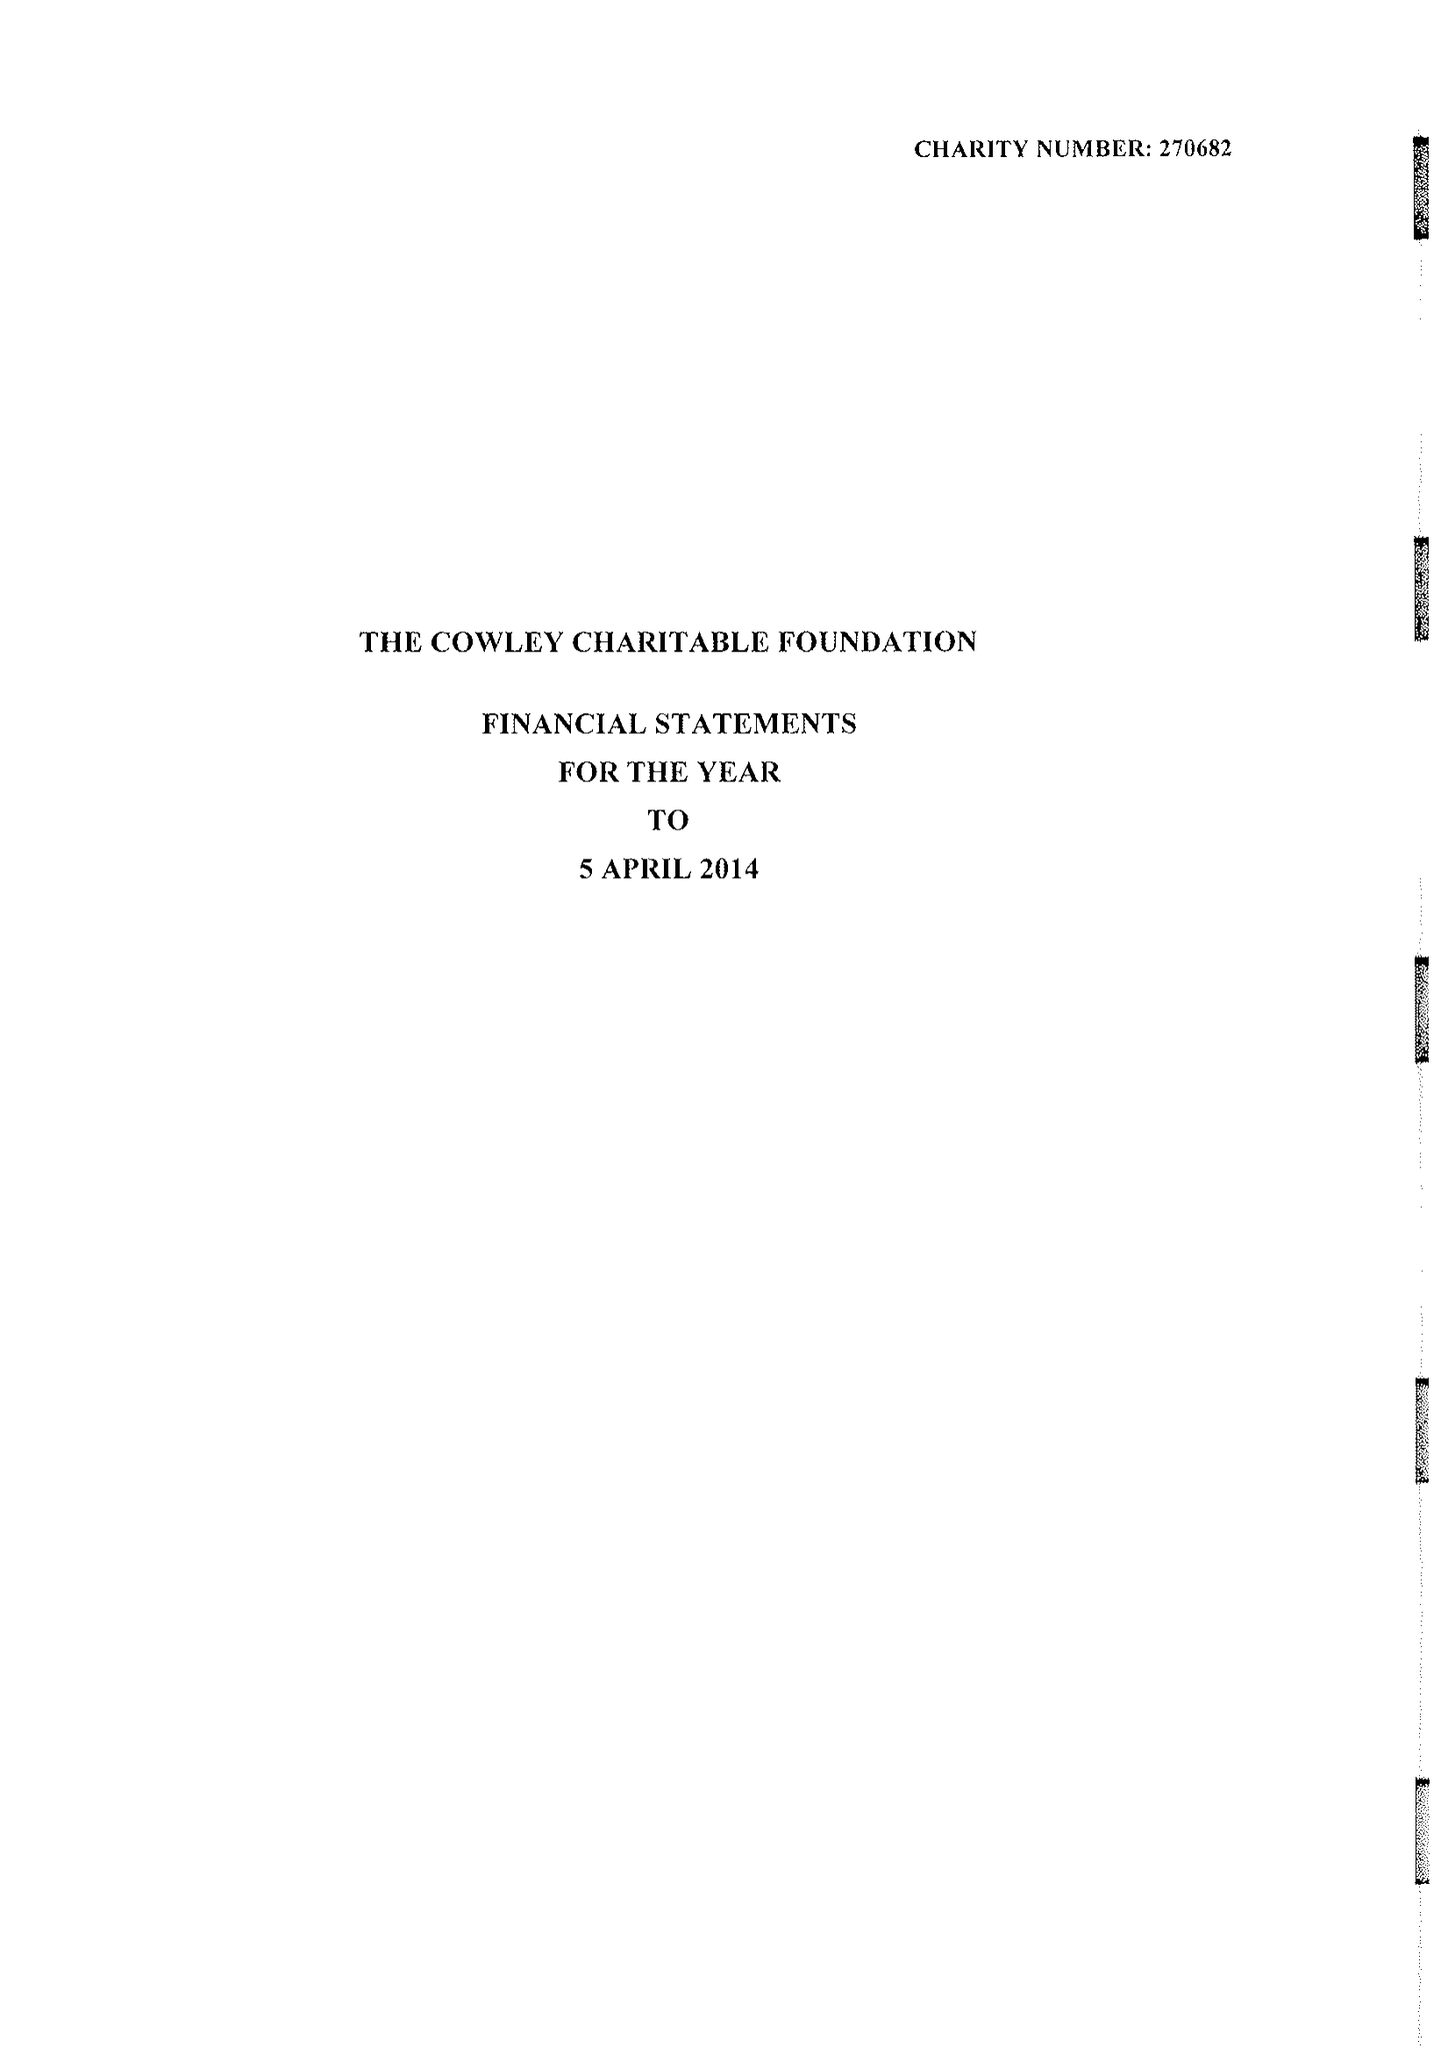What is the value for the spending_annually_in_british_pounds?
Answer the question using a single word or phrase. 33630.00 